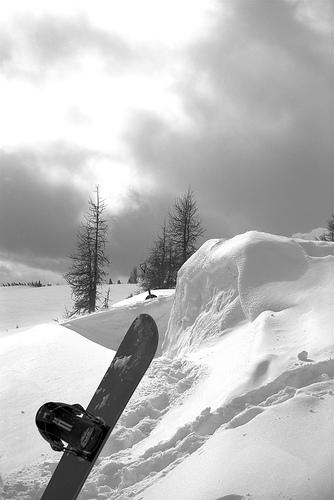Choose one object in the picture and provide a brief description of it. A shovel handle sticking out of the snow in the distance, which seems to be stuck. Select a referential expression grounding task for identifying a specific object in the image. Find the coordinates of the snow-covered rock within the snowy landscape. What type of VQA task can be performed using the footprints and tracks in the image? Identifying the type of tracks in the snow, such as human, animal or vehicle tracks. Give a brief summary of the image if it were to be used for a product advertisement. A winter scene featuring a snowboard with boot bindings standing in the snow, surrounded by footprints and tracks in a snow-filled landscape, perfect for showcasing the snowboard's durability and performance. What is the main object in the image that is typically used for winter sports? A black snowboard stuck vertically in the snow with a boot binding. Name the objects you can find on the black snowboard. Boot binding, boot strap, snow, and boot attached to the snowboard. Identify the trees in the image and their condition on the landscape. Bare trees on a snowy hillside, barren trees on a mountain ridge, a line of trees on the horizon, and trees with no leaves. Describe the overall atmosphere in the image by referring to the sky and weather. The sky is filled with dark clouds and the sun is trying to break through them, creating a bright, cloudy atmosphere. Mention some of the features related to the snow-covered landscape. Tracks and footprints in the snow, snow-covered rocks, a snow drift, and a snow pile. Suppose you are narrating the image for a visual entailment task, describe the relationship between the objects and environment. A black snowboard is the main focus, surrounded by tracks and footprints in the snow, which conveys a popular winter sport activity, while the bare trees and dark snow-filled clouds indicate a cold and cloudy day. 